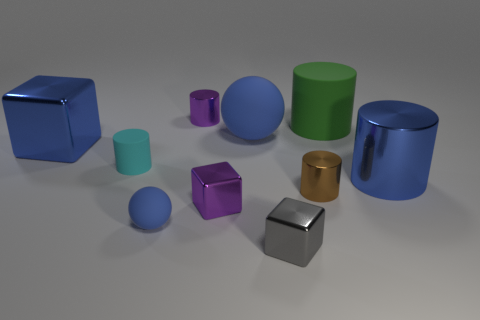Is the shape of the purple object that is in front of the tiny purple metal cylinder the same as the blue matte thing left of the purple block?
Your answer should be very brief. No. What is the shape of the gray shiny object that is the same size as the purple cube?
Provide a succinct answer. Cube. Is the cylinder that is left of the purple metallic cylinder made of the same material as the tiny object that is in front of the small blue object?
Give a very brief answer. No. Is there a brown cylinder that is on the right side of the matte cylinder that is to the right of the tiny purple cylinder?
Your response must be concise. No. There is another small block that is made of the same material as the purple block; what color is it?
Your answer should be very brief. Gray. Is the number of large yellow shiny blocks greater than the number of green cylinders?
Give a very brief answer. No. How many objects are either small matte cylinders in front of the green thing or tiny cyan rubber blocks?
Ensure brevity in your answer.  1. Is there a brown cylinder of the same size as the gray metal cube?
Your answer should be very brief. Yes. Is the number of green spheres less than the number of purple shiny cylinders?
Offer a terse response. Yes. How many balls are big blue matte things or blue matte things?
Offer a terse response. 2. 